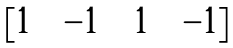<formula> <loc_0><loc_0><loc_500><loc_500>\begin{bmatrix} 1 & & - 1 & & 1 & & - 1 \end{bmatrix}</formula> 